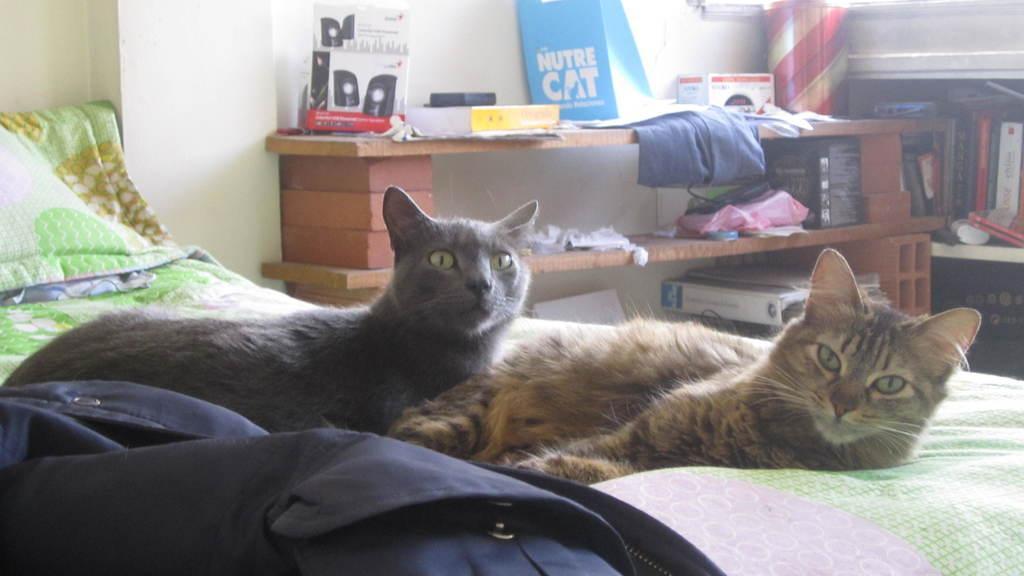In one or two sentences, can you explain what this image depicts? In the foreground of the image we can see two cats on the bed. In the background, we can see several items placed on table and group of books in a rack. 